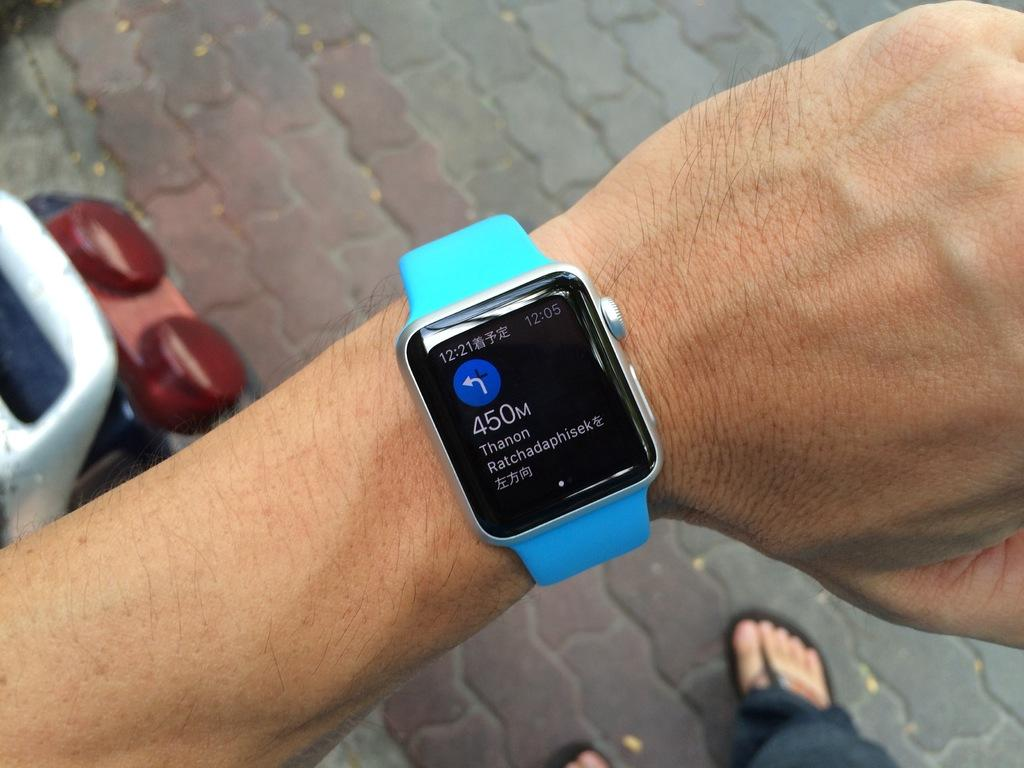Provide a one-sentence caption for the provided image. a smart watch with a black face on which is written 450 m. 